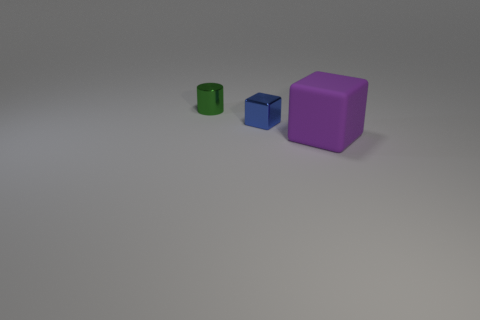Add 3 tiny brown matte cylinders. How many objects exist? 6 Subtract all cylinders. How many objects are left? 2 Add 2 shiny cubes. How many shiny cubes are left? 3 Add 1 purple matte cubes. How many purple matte cubes exist? 2 Subtract 0 brown cubes. How many objects are left? 3 Subtract all big cyan metal blocks. Subtract all green shiny things. How many objects are left? 2 